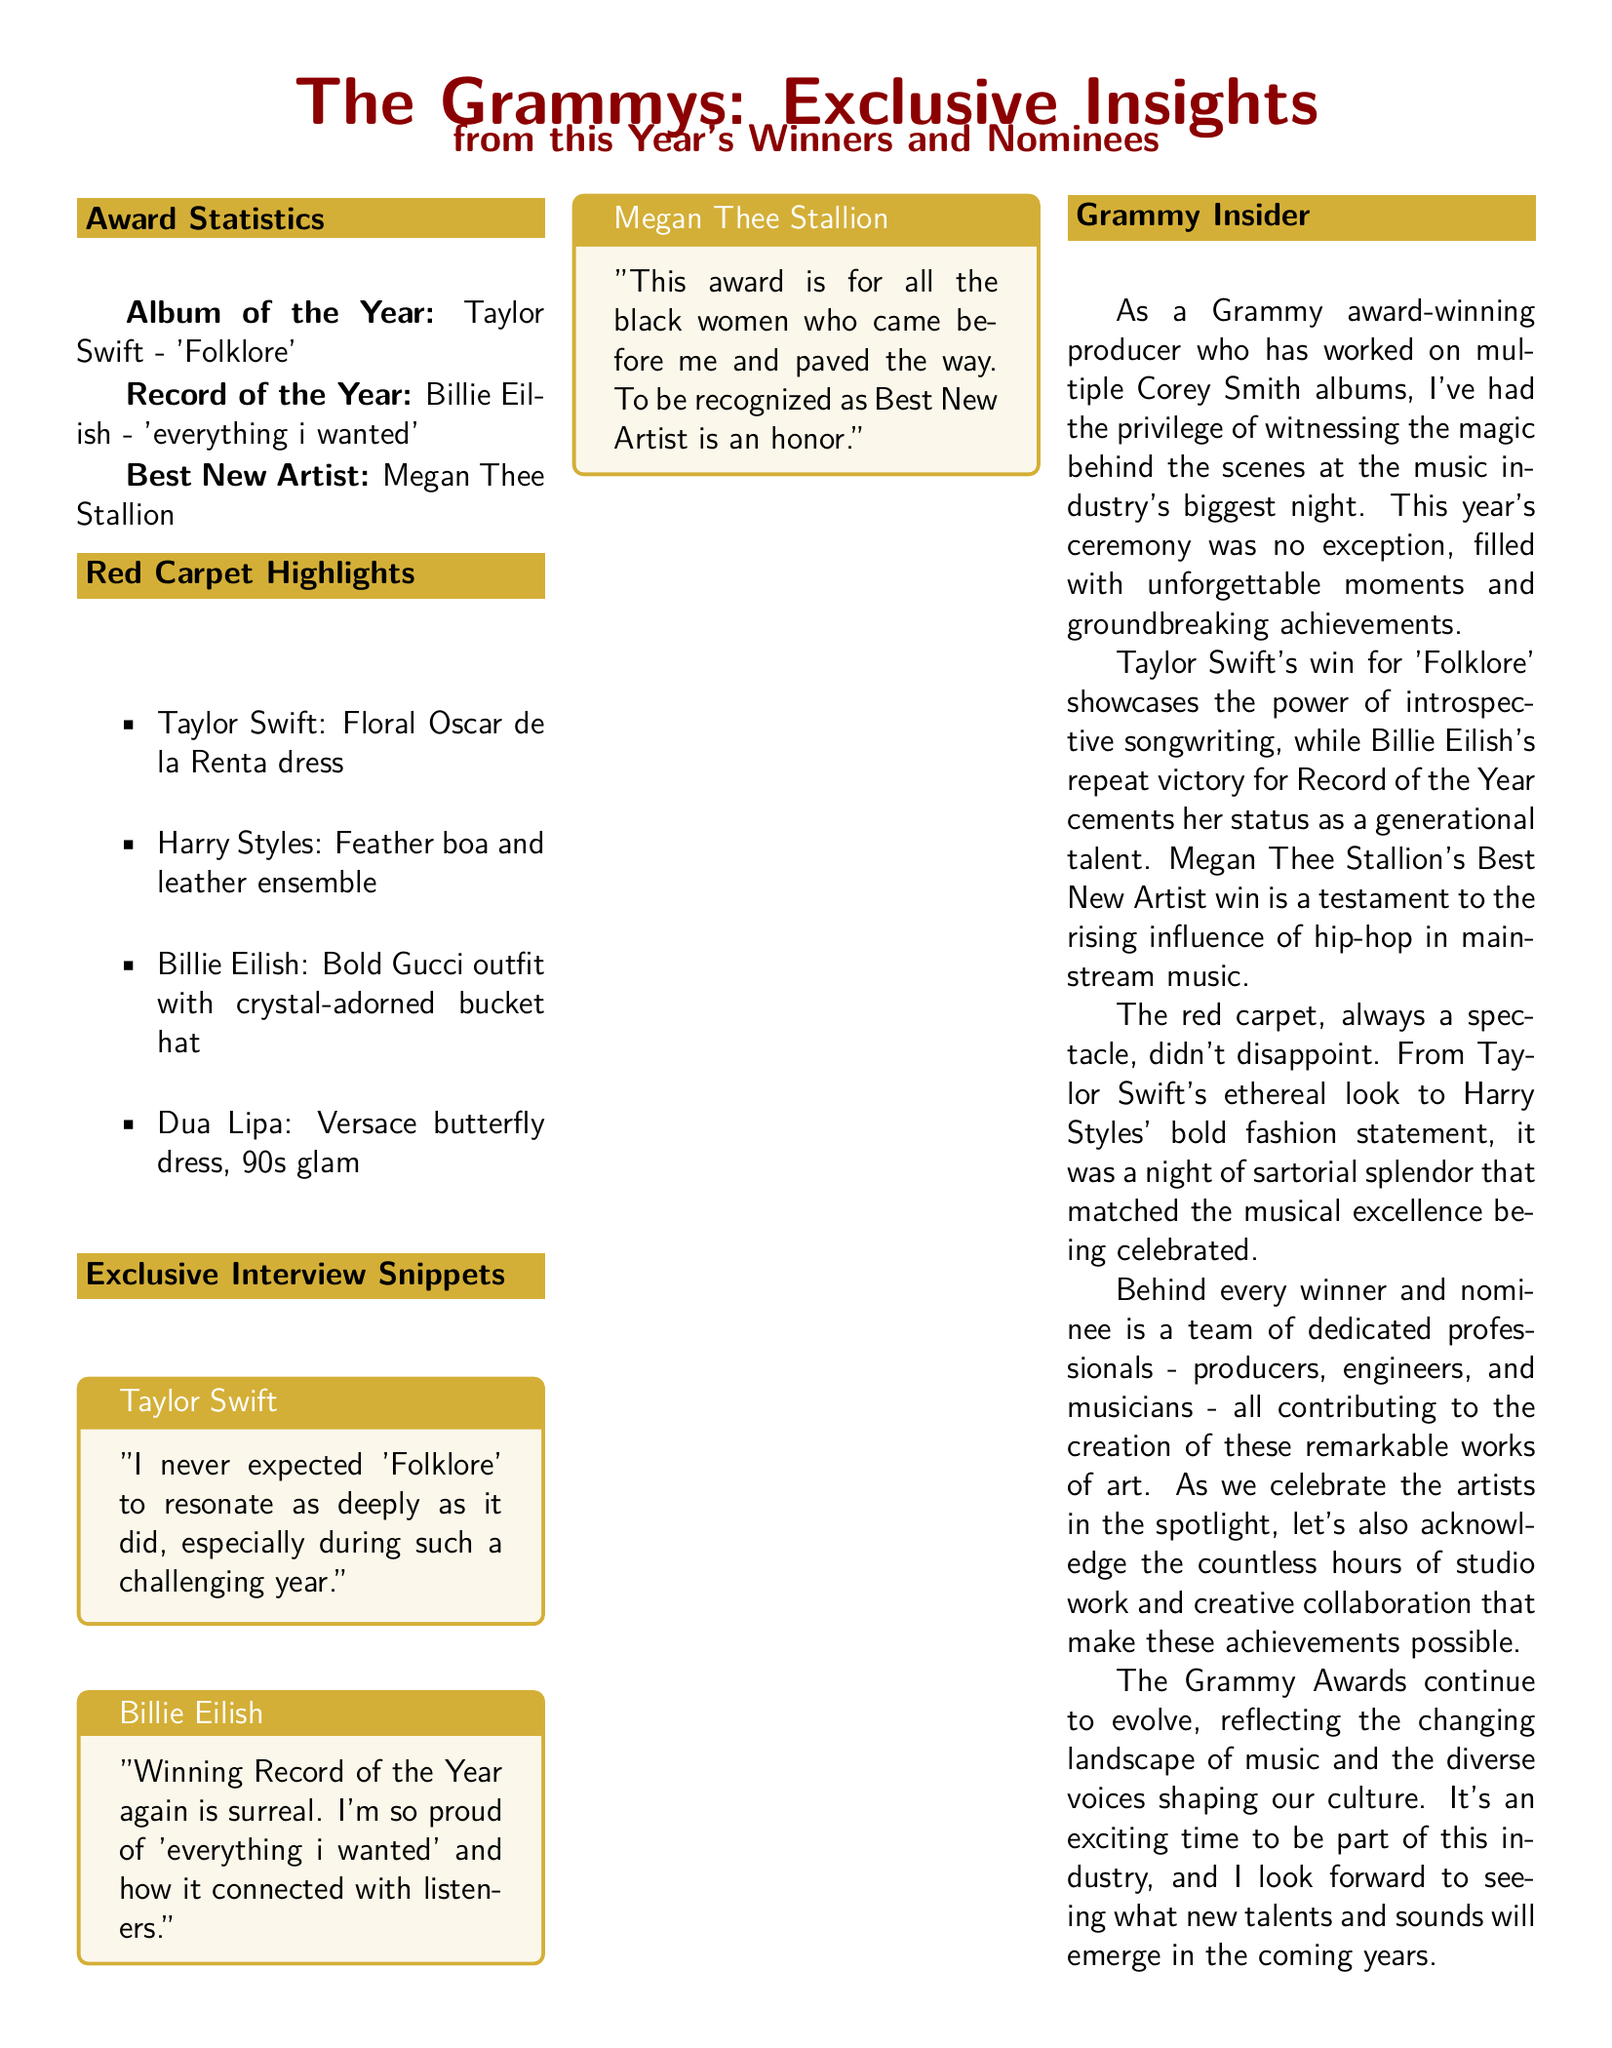What album won Album of the Year? The award for Album of the Year was given to Taylor Swift for her album 'Folklore'.
Answer: 'Folklore' Who won Record of the Year? The document states that Billie Eilish won the Record of the Year for her song 'everything i wanted'.
Answer: Billie Eilish What fashion brand did Taylor Swift wear on the red carpet? The document mentions that Taylor Swift wore a floral dress from Oscar de la Renta on the red carpet.
Answer: Oscar de la Renta How many new artists were nominated this year? The document highlights one winner for Best New Artist, which is Megan Thee Stallion; the number of other nominees is not provided.
Answer: 1 What did Billie Eilish say about her win? Billie Eilish expressed that winning Record of the Year felt surreal and she was proud of her song.
Answer: "Winning Record of the Year again is surreal." Which artist's win is described as a testament to hip-hop's influence? The document states that Megan Thee Stallion's win for Best New Artist reflects the rising influence of hip-hop.
Answer: Megan Thee Stallion What color is the award theme mentioned in the document? The predominant color associated with the awards, as indicated in design elements, is gold (grammy_gold).
Answer: Gold What type of document layout is used for presenting the Grammy insights? The document is formatted as a newspaper layout, highlighting various sections and insights about the Grammy Awards.
Answer: Newspaper layout 